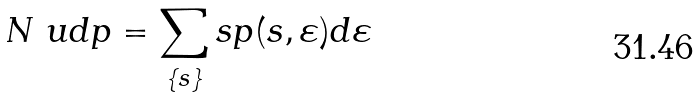<formula> <loc_0><loc_0><loc_500><loc_500>N \ u d p = \sum _ { \{ s \} } s p ( s , \varepsilon ) d \varepsilon</formula> 